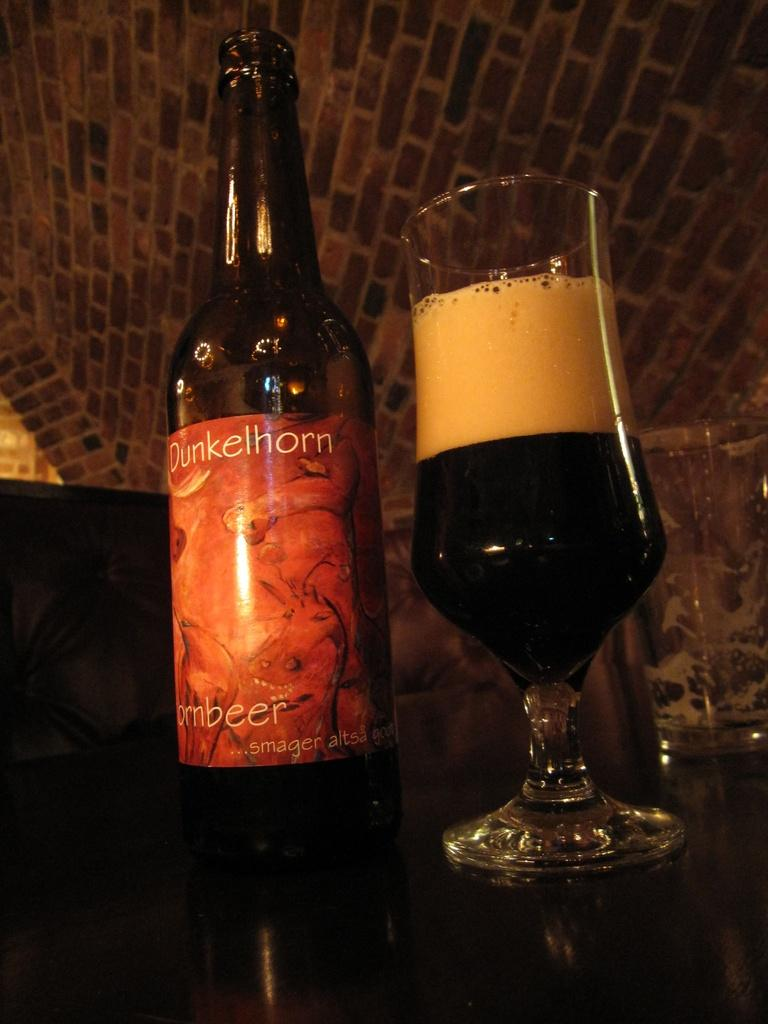What is one of the objects in the image? There is a bottle in the image. What else can be seen in the image related to beverages? There is a glass with a drink in the image. What type of peace symbol can be seen in the image? There is no peace symbol present in the image. How many lines are visible in the image? The number of lines cannot be determined from the provided facts, as the image does not contain any line-based objects or features. 